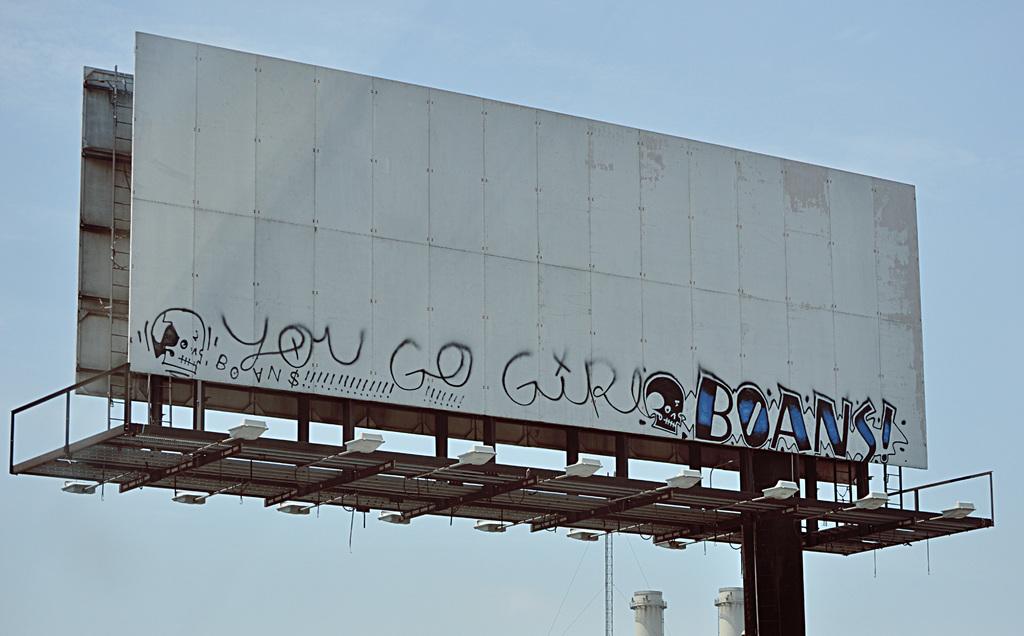Who should go?
Your answer should be very brief. Girl. 